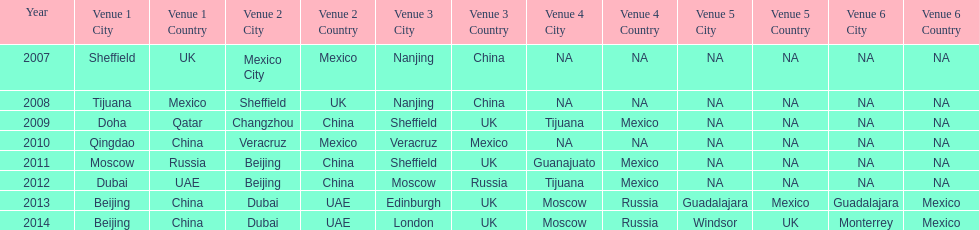What years had the most venues? 2013, 2014. 